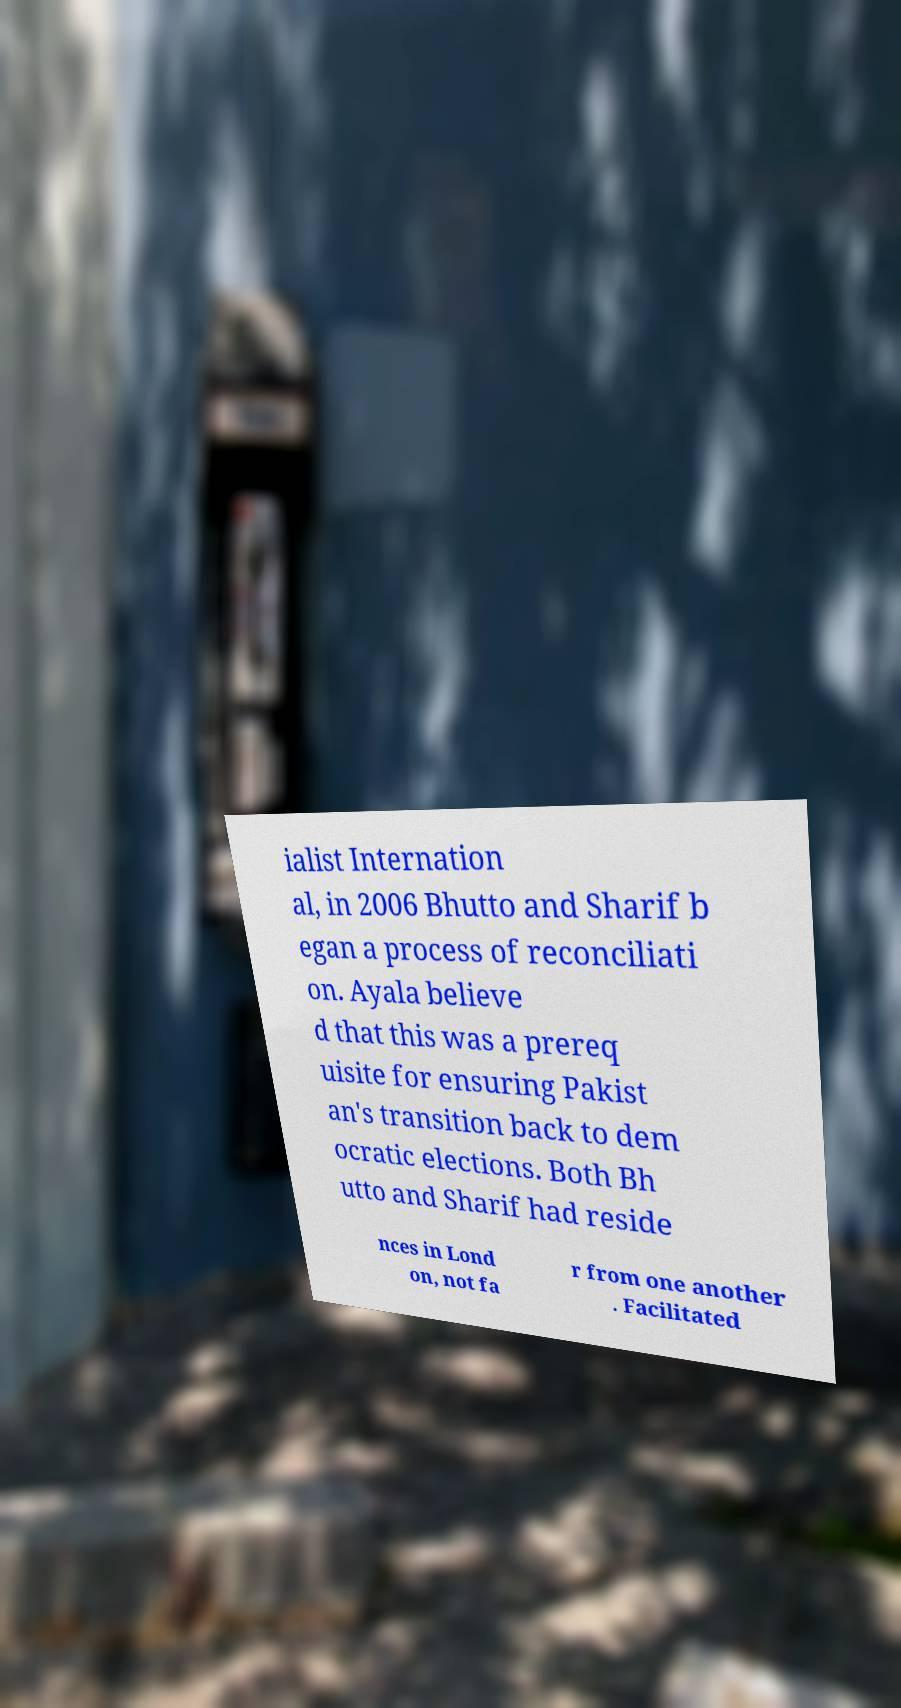Could you extract and type out the text from this image? ialist Internation al, in 2006 Bhutto and Sharif b egan a process of reconciliati on. Ayala believe d that this was a prereq uisite for ensuring Pakist an's transition back to dem ocratic elections. Both Bh utto and Sharif had reside nces in Lond on, not fa r from one another . Facilitated 